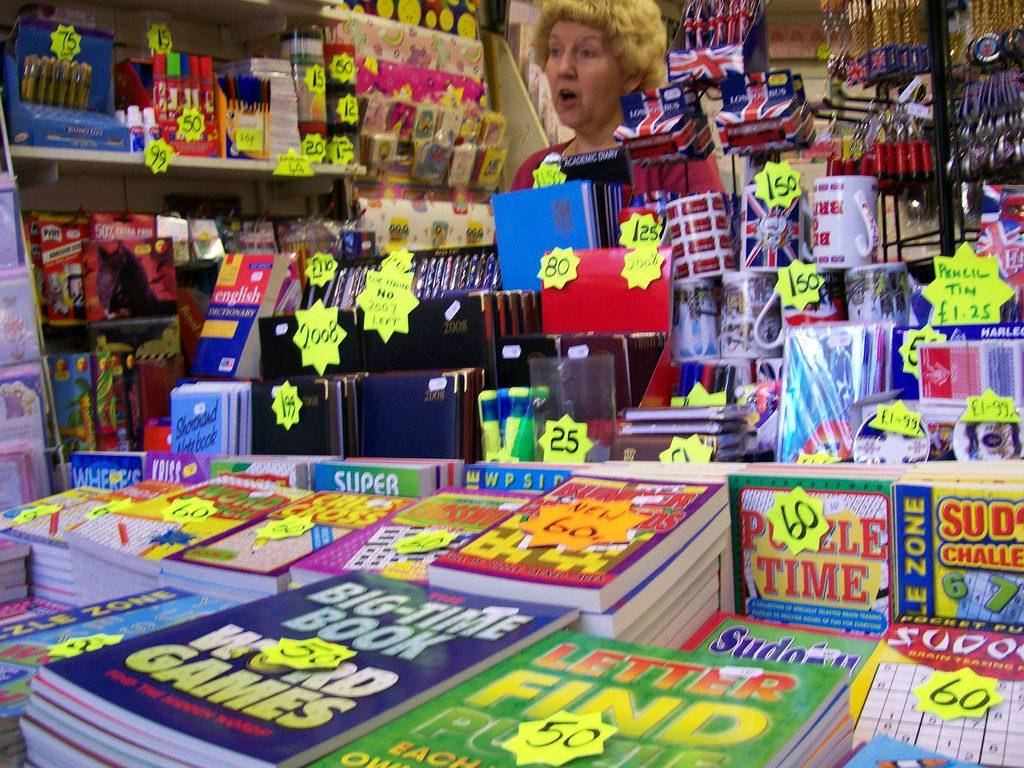<image>
Create a compact narrative representing the image presented. a bookstore has a lot of different books on display such as sudoku and letter finds 